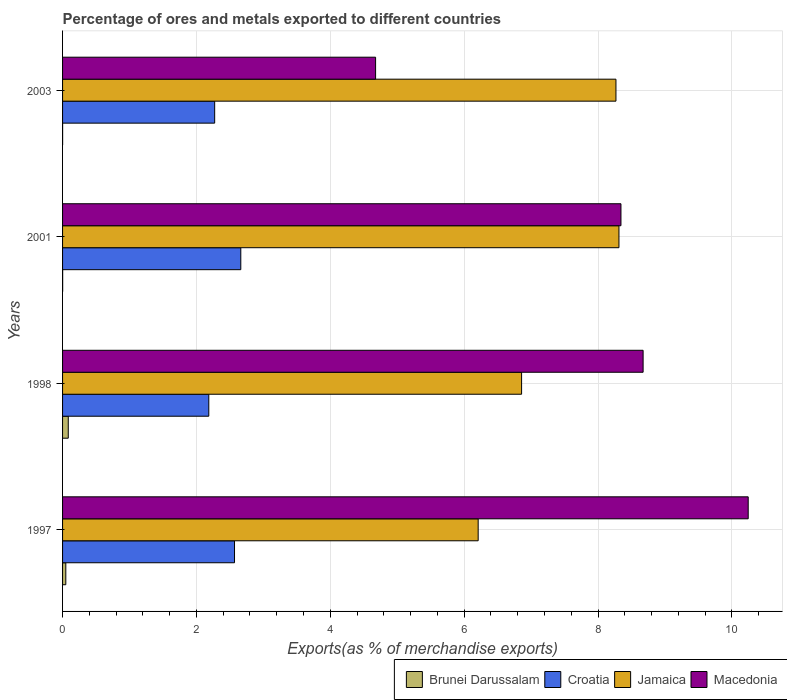Are the number of bars per tick equal to the number of legend labels?
Provide a succinct answer. Yes. What is the label of the 2nd group of bars from the top?
Offer a terse response. 2001. In how many cases, is the number of bars for a given year not equal to the number of legend labels?
Offer a very short reply. 0. What is the percentage of exports to different countries in Croatia in 1998?
Ensure brevity in your answer.  2.18. Across all years, what is the maximum percentage of exports to different countries in Brunei Darussalam?
Your response must be concise. 0.09. Across all years, what is the minimum percentage of exports to different countries in Jamaica?
Provide a succinct answer. 6.21. In which year was the percentage of exports to different countries in Croatia minimum?
Your response must be concise. 1998. What is the total percentage of exports to different countries in Jamaica in the graph?
Keep it short and to the point. 29.65. What is the difference between the percentage of exports to different countries in Macedonia in 1998 and that in 2003?
Offer a terse response. 4. What is the difference between the percentage of exports to different countries in Jamaica in 1998 and the percentage of exports to different countries in Macedonia in 2003?
Provide a short and direct response. 2.18. What is the average percentage of exports to different countries in Jamaica per year?
Ensure brevity in your answer.  7.41. In the year 1997, what is the difference between the percentage of exports to different countries in Croatia and percentage of exports to different countries in Jamaica?
Give a very brief answer. -3.64. In how many years, is the percentage of exports to different countries in Macedonia greater than 7.2 %?
Offer a very short reply. 3. What is the ratio of the percentage of exports to different countries in Croatia in 2001 to that in 2003?
Ensure brevity in your answer.  1.17. Is the difference between the percentage of exports to different countries in Croatia in 1997 and 2001 greater than the difference between the percentage of exports to different countries in Jamaica in 1997 and 2001?
Keep it short and to the point. Yes. What is the difference between the highest and the second highest percentage of exports to different countries in Brunei Darussalam?
Provide a succinct answer. 0.04. What is the difference between the highest and the lowest percentage of exports to different countries in Macedonia?
Your answer should be compact. 5.57. Is the sum of the percentage of exports to different countries in Jamaica in 1997 and 1998 greater than the maximum percentage of exports to different countries in Croatia across all years?
Your answer should be very brief. Yes. Is it the case that in every year, the sum of the percentage of exports to different countries in Jamaica and percentage of exports to different countries in Croatia is greater than the sum of percentage of exports to different countries in Brunei Darussalam and percentage of exports to different countries in Macedonia?
Your answer should be compact. No. What does the 2nd bar from the top in 2001 represents?
Ensure brevity in your answer.  Jamaica. What does the 3rd bar from the bottom in 1997 represents?
Offer a very short reply. Jamaica. Is it the case that in every year, the sum of the percentage of exports to different countries in Croatia and percentage of exports to different countries in Macedonia is greater than the percentage of exports to different countries in Jamaica?
Offer a terse response. No. How many bars are there?
Offer a very short reply. 16. Are all the bars in the graph horizontal?
Your answer should be very brief. Yes. How many years are there in the graph?
Provide a short and direct response. 4. What is the difference between two consecutive major ticks on the X-axis?
Offer a very short reply. 2. Are the values on the major ticks of X-axis written in scientific E-notation?
Give a very brief answer. No. Does the graph contain grids?
Ensure brevity in your answer.  Yes. How are the legend labels stacked?
Make the answer very short. Horizontal. What is the title of the graph?
Make the answer very short. Percentage of ores and metals exported to different countries. Does "Cambodia" appear as one of the legend labels in the graph?
Keep it short and to the point. No. What is the label or title of the X-axis?
Offer a very short reply. Exports(as % of merchandise exports). What is the label or title of the Y-axis?
Your answer should be very brief. Years. What is the Exports(as % of merchandise exports) of Brunei Darussalam in 1997?
Offer a very short reply. 0.05. What is the Exports(as % of merchandise exports) in Croatia in 1997?
Provide a succinct answer. 2.57. What is the Exports(as % of merchandise exports) in Jamaica in 1997?
Offer a very short reply. 6.21. What is the Exports(as % of merchandise exports) of Macedonia in 1997?
Make the answer very short. 10.24. What is the Exports(as % of merchandise exports) in Brunei Darussalam in 1998?
Offer a very short reply. 0.09. What is the Exports(as % of merchandise exports) in Croatia in 1998?
Your answer should be compact. 2.18. What is the Exports(as % of merchandise exports) in Jamaica in 1998?
Your answer should be very brief. 6.86. What is the Exports(as % of merchandise exports) in Macedonia in 1998?
Make the answer very short. 8.67. What is the Exports(as % of merchandise exports) of Brunei Darussalam in 2001?
Give a very brief answer. 0. What is the Exports(as % of merchandise exports) in Croatia in 2001?
Ensure brevity in your answer.  2.66. What is the Exports(as % of merchandise exports) of Jamaica in 2001?
Give a very brief answer. 8.31. What is the Exports(as % of merchandise exports) of Macedonia in 2001?
Ensure brevity in your answer.  8.34. What is the Exports(as % of merchandise exports) of Brunei Darussalam in 2003?
Offer a terse response. 0. What is the Exports(as % of merchandise exports) in Croatia in 2003?
Keep it short and to the point. 2.27. What is the Exports(as % of merchandise exports) of Jamaica in 2003?
Give a very brief answer. 8.27. What is the Exports(as % of merchandise exports) in Macedonia in 2003?
Offer a terse response. 4.68. Across all years, what is the maximum Exports(as % of merchandise exports) of Brunei Darussalam?
Give a very brief answer. 0.09. Across all years, what is the maximum Exports(as % of merchandise exports) of Croatia?
Your response must be concise. 2.66. Across all years, what is the maximum Exports(as % of merchandise exports) in Jamaica?
Your answer should be compact. 8.31. Across all years, what is the maximum Exports(as % of merchandise exports) of Macedonia?
Offer a very short reply. 10.24. Across all years, what is the minimum Exports(as % of merchandise exports) in Brunei Darussalam?
Make the answer very short. 0. Across all years, what is the minimum Exports(as % of merchandise exports) in Croatia?
Offer a terse response. 2.18. Across all years, what is the minimum Exports(as % of merchandise exports) in Jamaica?
Give a very brief answer. 6.21. Across all years, what is the minimum Exports(as % of merchandise exports) of Macedonia?
Make the answer very short. 4.68. What is the total Exports(as % of merchandise exports) of Brunei Darussalam in the graph?
Keep it short and to the point. 0.14. What is the total Exports(as % of merchandise exports) of Croatia in the graph?
Offer a terse response. 9.69. What is the total Exports(as % of merchandise exports) in Jamaica in the graph?
Keep it short and to the point. 29.65. What is the total Exports(as % of merchandise exports) in Macedonia in the graph?
Your answer should be compact. 31.94. What is the difference between the Exports(as % of merchandise exports) in Brunei Darussalam in 1997 and that in 1998?
Offer a very short reply. -0.04. What is the difference between the Exports(as % of merchandise exports) of Croatia in 1997 and that in 1998?
Ensure brevity in your answer.  0.38. What is the difference between the Exports(as % of merchandise exports) of Jamaica in 1997 and that in 1998?
Your answer should be very brief. -0.65. What is the difference between the Exports(as % of merchandise exports) in Macedonia in 1997 and that in 1998?
Offer a very short reply. 1.57. What is the difference between the Exports(as % of merchandise exports) of Brunei Darussalam in 1997 and that in 2001?
Offer a terse response. 0.05. What is the difference between the Exports(as % of merchandise exports) in Croatia in 1997 and that in 2001?
Ensure brevity in your answer.  -0.09. What is the difference between the Exports(as % of merchandise exports) in Jamaica in 1997 and that in 2001?
Keep it short and to the point. -2.1. What is the difference between the Exports(as % of merchandise exports) in Macedonia in 1997 and that in 2001?
Provide a succinct answer. 1.9. What is the difference between the Exports(as % of merchandise exports) in Brunei Darussalam in 1997 and that in 2003?
Your response must be concise. 0.05. What is the difference between the Exports(as % of merchandise exports) of Croatia in 1997 and that in 2003?
Keep it short and to the point. 0.3. What is the difference between the Exports(as % of merchandise exports) of Jamaica in 1997 and that in 2003?
Provide a short and direct response. -2.06. What is the difference between the Exports(as % of merchandise exports) in Macedonia in 1997 and that in 2003?
Provide a short and direct response. 5.57. What is the difference between the Exports(as % of merchandise exports) of Brunei Darussalam in 1998 and that in 2001?
Provide a short and direct response. 0.08. What is the difference between the Exports(as % of merchandise exports) of Croatia in 1998 and that in 2001?
Provide a short and direct response. -0.48. What is the difference between the Exports(as % of merchandise exports) of Jamaica in 1998 and that in 2001?
Provide a succinct answer. -1.45. What is the difference between the Exports(as % of merchandise exports) in Macedonia in 1998 and that in 2001?
Your answer should be very brief. 0.33. What is the difference between the Exports(as % of merchandise exports) of Brunei Darussalam in 1998 and that in 2003?
Keep it short and to the point. 0.08. What is the difference between the Exports(as % of merchandise exports) of Croatia in 1998 and that in 2003?
Keep it short and to the point. -0.09. What is the difference between the Exports(as % of merchandise exports) of Jamaica in 1998 and that in 2003?
Offer a very short reply. -1.41. What is the difference between the Exports(as % of merchandise exports) in Macedonia in 1998 and that in 2003?
Provide a short and direct response. 4. What is the difference between the Exports(as % of merchandise exports) of Croatia in 2001 and that in 2003?
Give a very brief answer. 0.39. What is the difference between the Exports(as % of merchandise exports) in Jamaica in 2001 and that in 2003?
Provide a succinct answer. 0.04. What is the difference between the Exports(as % of merchandise exports) in Macedonia in 2001 and that in 2003?
Provide a short and direct response. 3.67. What is the difference between the Exports(as % of merchandise exports) in Brunei Darussalam in 1997 and the Exports(as % of merchandise exports) in Croatia in 1998?
Make the answer very short. -2.14. What is the difference between the Exports(as % of merchandise exports) of Brunei Darussalam in 1997 and the Exports(as % of merchandise exports) of Jamaica in 1998?
Make the answer very short. -6.81. What is the difference between the Exports(as % of merchandise exports) in Brunei Darussalam in 1997 and the Exports(as % of merchandise exports) in Macedonia in 1998?
Your answer should be compact. -8.62. What is the difference between the Exports(as % of merchandise exports) of Croatia in 1997 and the Exports(as % of merchandise exports) of Jamaica in 1998?
Your answer should be very brief. -4.29. What is the difference between the Exports(as % of merchandise exports) of Croatia in 1997 and the Exports(as % of merchandise exports) of Macedonia in 1998?
Offer a terse response. -6.1. What is the difference between the Exports(as % of merchandise exports) in Jamaica in 1997 and the Exports(as % of merchandise exports) in Macedonia in 1998?
Make the answer very short. -2.46. What is the difference between the Exports(as % of merchandise exports) in Brunei Darussalam in 1997 and the Exports(as % of merchandise exports) in Croatia in 2001?
Make the answer very short. -2.61. What is the difference between the Exports(as % of merchandise exports) in Brunei Darussalam in 1997 and the Exports(as % of merchandise exports) in Jamaica in 2001?
Offer a very short reply. -8.26. What is the difference between the Exports(as % of merchandise exports) in Brunei Darussalam in 1997 and the Exports(as % of merchandise exports) in Macedonia in 2001?
Your answer should be compact. -8.29. What is the difference between the Exports(as % of merchandise exports) in Croatia in 1997 and the Exports(as % of merchandise exports) in Jamaica in 2001?
Offer a terse response. -5.74. What is the difference between the Exports(as % of merchandise exports) of Croatia in 1997 and the Exports(as % of merchandise exports) of Macedonia in 2001?
Give a very brief answer. -5.77. What is the difference between the Exports(as % of merchandise exports) of Jamaica in 1997 and the Exports(as % of merchandise exports) of Macedonia in 2001?
Offer a terse response. -2.13. What is the difference between the Exports(as % of merchandise exports) in Brunei Darussalam in 1997 and the Exports(as % of merchandise exports) in Croatia in 2003?
Provide a succinct answer. -2.22. What is the difference between the Exports(as % of merchandise exports) in Brunei Darussalam in 1997 and the Exports(as % of merchandise exports) in Jamaica in 2003?
Provide a short and direct response. -8.22. What is the difference between the Exports(as % of merchandise exports) in Brunei Darussalam in 1997 and the Exports(as % of merchandise exports) in Macedonia in 2003?
Your answer should be compact. -4.63. What is the difference between the Exports(as % of merchandise exports) in Croatia in 1997 and the Exports(as % of merchandise exports) in Jamaica in 2003?
Offer a very short reply. -5.7. What is the difference between the Exports(as % of merchandise exports) in Croatia in 1997 and the Exports(as % of merchandise exports) in Macedonia in 2003?
Your answer should be compact. -2.11. What is the difference between the Exports(as % of merchandise exports) of Jamaica in 1997 and the Exports(as % of merchandise exports) of Macedonia in 2003?
Offer a terse response. 1.53. What is the difference between the Exports(as % of merchandise exports) in Brunei Darussalam in 1998 and the Exports(as % of merchandise exports) in Croatia in 2001?
Provide a succinct answer. -2.58. What is the difference between the Exports(as % of merchandise exports) of Brunei Darussalam in 1998 and the Exports(as % of merchandise exports) of Jamaica in 2001?
Give a very brief answer. -8.23. What is the difference between the Exports(as % of merchandise exports) in Brunei Darussalam in 1998 and the Exports(as % of merchandise exports) in Macedonia in 2001?
Offer a very short reply. -8.26. What is the difference between the Exports(as % of merchandise exports) in Croatia in 1998 and the Exports(as % of merchandise exports) in Jamaica in 2001?
Keep it short and to the point. -6.13. What is the difference between the Exports(as % of merchandise exports) of Croatia in 1998 and the Exports(as % of merchandise exports) of Macedonia in 2001?
Provide a succinct answer. -6.16. What is the difference between the Exports(as % of merchandise exports) of Jamaica in 1998 and the Exports(as % of merchandise exports) of Macedonia in 2001?
Provide a succinct answer. -1.48. What is the difference between the Exports(as % of merchandise exports) in Brunei Darussalam in 1998 and the Exports(as % of merchandise exports) in Croatia in 2003?
Provide a succinct answer. -2.19. What is the difference between the Exports(as % of merchandise exports) in Brunei Darussalam in 1998 and the Exports(as % of merchandise exports) in Jamaica in 2003?
Your answer should be very brief. -8.18. What is the difference between the Exports(as % of merchandise exports) in Brunei Darussalam in 1998 and the Exports(as % of merchandise exports) in Macedonia in 2003?
Your answer should be very brief. -4.59. What is the difference between the Exports(as % of merchandise exports) of Croatia in 1998 and the Exports(as % of merchandise exports) of Jamaica in 2003?
Offer a very short reply. -6.08. What is the difference between the Exports(as % of merchandise exports) in Croatia in 1998 and the Exports(as % of merchandise exports) in Macedonia in 2003?
Offer a terse response. -2.49. What is the difference between the Exports(as % of merchandise exports) in Jamaica in 1998 and the Exports(as % of merchandise exports) in Macedonia in 2003?
Make the answer very short. 2.18. What is the difference between the Exports(as % of merchandise exports) in Brunei Darussalam in 2001 and the Exports(as % of merchandise exports) in Croatia in 2003?
Ensure brevity in your answer.  -2.27. What is the difference between the Exports(as % of merchandise exports) in Brunei Darussalam in 2001 and the Exports(as % of merchandise exports) in Jamaica in 2003?
Your response must be concise. -8.27. What is the difference between the Exports(as % of merchandise exports) in Brunei Darussalam in 2001 and the Exports(as % of merchandise exports) in Macedonia in 2003?
Give a very brief answer. -4.68. What is the difference between the Exports(as % of merchandise exports) of Croatia in 2001 and the Exports(as % of merchandise exports) of Jamaica in 2003?
Your response must be concise. -5.6. What is the difference between the Exports(as % of merchandise exports) of Croatia in 2001 and the Exports(as % of merchandise exports) of Macedonia in 2003?
Give a very brief answer. -2.01. What is the difference between the Exports(as % of merchandise exports) of Jamaica in 2001 and the Exports(as % of merchandise exports) of Macedonia in 2003?
Give a very brief answer. 3.64. What is the average Exports(as % of merchandise exports) of Brunei Darussalam per year?
Give a very brief answer. 0.03. What is the average Exports(as % of merchandise exports) of Croatia per year?
Ensure brevity in your answer.  2.42. What is the average Exports(as % of merchandise exports) in Jamaica per year?
Keep it short and to the point. 7.41. What is the average Exports(as % of merchandise exports) in Macedonia per year?
Keep it short and to the point. 7.98. In the year 1997, what is the difference between the Exports(as % of merchandise exports) in Brunei Darussalam and Exports(as % of merchandise exports) in Croatia?
Make the answer very short. -2.52. In the year 1997, what is the difference between the Exports(as % of merchandise exports) of Brunei Darussalam and Exports(as % of merchandise exports) of Jamaica?
Your answer should be compact. -6.16. In the year 1997, what is the difference between the Exports(as % of merchandise exports) of Brunei Darussalam and Exports(as % of merchandise exports) of Macedonia?
Your answer should be very brief. -10.19. In the year 1997, what is the difference between the Exports(as % of merchandise exports) in Croatia and Exports(as % of merchandise exports) in Jamaica?
Your answer should be very brief. -3.64. In the year 1997, what is the difference between the Exports(as % of merchandise exports) in Croatia and Exports(as % of merchandise exports) in Macedonia?
Your response must be concise. -7.67. In the year 1997, what is the difference between the Exports(as % of merchandise exports) in Jamaica and Exports(as % of merchandise exports) in Macedonia?
Your answer should be very brief. -4.03. In the year 1998, what is the difference between the Exports(as % of merchandise exports) of Brunei Darussalam and Exports(as % of merchandise exports) of Croatia?
Keep it short and to the point. -2.1. In the year 1998, what is the difference between the Exports(as % of merchandise exports) of Brunei Darussalam and Exports(as % of merchandise exports) of Jamaica?
Provide a short and direct response. -6.77. In the year 1998, what is the difference between the Exports(as % of merchandise exports) in Brunei Darussalam and Exports(as % of merchandise exports) in Macedonia?
Your answer should be compact. -8.59. In the year 1998, what is the difference between the Exports(as % of merchandise exports) of Croatia and Exports(as % of merchandise exports) of Jamaica?
Ensure brevity in your answer.  -4.67. In the year 1998, what is the difference between the Exports(as % of merchandise exports) in Croatia and Exports(as % of merchandise exports) in Macedonia?
Make the answer very short. -6.49. In the year 1998, what is the difference between the Exports(as % of merchandise exports) of Jamaica and Exports(as % of merchandise exports) of Macedonia?
Make the answer very short. -1.82. In the year 2001, what is the difference between the Exports(as % of merchandise exports) in Brunei Darussalam and Exports(as % of merchandise exports) in Croatia?
Your answer should be very brief. -2.66. In the year 2001, what is the difference between the Exports(as % of merchandise exports) of Brunei Darussalam and Exports(as % of merchandise exports) of Jamaica?
Make the answer very short. -8.31. In the year 2001, what is the difference between the Exports(as % of merchandise exports) in Brunei Darussalam and Exports(as % of merchandise exports) in Macedonia?
Make the answer very short. -8.34. In the year 2001, what is the difference between the Exports(as % of merchandise exports) in Croatia and Exports(as % of merchandise exports) in Jamaica?
Offer a very short reply. -5.65. In the year 2001, what is the difference between the Exports(as % of merchandise exports) of Croatia and Exports(as % of merchandise exports) of Macedonia?
Provide a short and direct response. -5.68. In the year 2001, what is the difference between the Exports(as % of merchandise exports) of Jamaica and Exports(as % of merchandise exports) of Macedonia?
Provide a succinct answer. -0.03. In the year 2003, what is the difference between the Exports(as % of merchandise exports) in Brunei Darussalam and Exports(as % of merchandise exports) in Croatia?
Offer a terse response. -2.27. In the year 2003, what is the difference between the Exports(as % of merchandise exports) of Brunei Darussalam and Exports(as % of merchandise exports) of Jamaica?
Offer a terse response. -8.27. In the year 2003, what is the difference between the Exports(as % of merchandise exports) in Brunei Darussalam and Exports(as % of merchandise exports) in Macedonia?
Provide a short and direct response. -4.68. In the year 2003, what is the difference between the Exports(as % of merchandise exports) in Croatia and Exports(as % of merchandise exports) in Jamaica?
Your response must be concise. -6. In the year 2003, what is the difference between the Exports(as % of merchandise exports) of Croatia and Exports(as % of merchandise exports) of Macedonia?
Offer a very short reply. -2.4. In the year 2003, what is the difference between the Exports(as % of merchandise exports) of Jamaica and Exports(as % of merchandise exports) of Macedonia?
Offer a terse response. 3.59. What is the ratio of the Exports(as % of merchandise exports) of Brunei Darussalam in 1997 to that in 1998?
Your response must be concise. 0.57. What is the ratio of the Exports(as % of merchandise exports) in Croatia in 1997 to that in 1998?
Make the answer very short. 1.18. What is the ratio of the Exports(as % of merchandise exports) of Jamaica in 1997 to that in 1998?
Your response must be concise. 0.91. What is the ratio of the Exports(as % of merchandise exports) in Macedonia in 1997 to that in 1998?
Give a very brief answer. 1.18. What is the ratio of the Exports(as % of merchandise exports) in Brunei Darussalam in 1997 to that in 2001?
Your answer should be compact. 39.21. What is the ratio of the Exports(as % of merchandise exports) in Croatia in 1997 to that in 2001?
Offer a terse response. 0.96. What is the ratio of the Exports(as % of merchandise exports) of Jamaica in 1997 to that in 2001?
Offer a very short reply. 0.75. What is the ratio of the Exports(as % of merchandise exports) in Macedonia in 1997 to that in 2001?
Make the answer very short. 1.23. What is the ratio of the Exports(as % of merchandise exports) in Brunei Darussalam in 1997 to that in 2003?
Provide a succinct answer. 64.77. What is the ratio of the Exports(as % of merchandise exports) of Croatia in 1997 to that in 2003?
Keep it short and to the point. 1.13. What is the ratio of the Exports(as % of merchandise exports) in Jamaica in 1997 to that in 2003?
Provide a short and direct response. 0.75. What is the ratio of the Exports(as % of merchandise exports) in Macedonia in 1997 to that in 2003?
Offer a very short reply. 2.19. What is the ratio of the Exports(as % of merchandise exports) in Brunei Darussalam in 1998 to that in 2001?
Provide a succinct answer. 68.75. What is the ratio of the Exports(as % of merchandise exports) of Croatia in 1998 to that in 2001?
Offer a very short reply. 0.82. What is the ratio of the Exports(as % of merchandise exports) of Jamaica in 1998 to that in 2001?
Offer a terse response. 0.82. What is the ratio of the Exports(as % of merchandise exports) in Macedonia in 1998 to that in 2001?
Offer a very short reply. 1.04. What is the ratio of the Exports(as % of merchandise exports) in Brunei Darussalam in 1998 to that in 2003?
Your answer should be compact. 113.56. What is the ratio of the Exports(as % of merchandise exports) of Croatia in 1998 to that in 2003?
Ensure brevity in your answer.  0.96. What is the ratio of the Exports(as % of merchandise exports) in Jamaica in 1998 to that in 2003?
Offer a very short reply. 0.83. What is the ratio of the Exports(as % of merchandise exports) of Macedonia in 1998 to that in 2003?
Your response must be concise. 1.85. What is the ratio of the Exports(as % of merchandise exports) in Brunei Darussalam in 2001 to that in 2003?
Provide a succinct answer. 1.65. What is the ratio of the Exports(as % of merchandise exports) of Croatia in 2001 to that in 2003?
Ensure brevity in your answer.  1.17. What is the ratio of the Exports(as % of merchandise exports) of Jamaica in 2001 to that in 2003?
Offer a very short reply. 1.01. What is the ratio of the Exports(as % of merchandise exports) of Macedonia in 2001 to that in 2003?
Your answer should be compact. 1.78. What is the difference between the highest and the second highest Exports(as % of merchandise exports) in Brunei Darussalam?
Make the answer very short. 0.04. What is the difference between the highest and the second highest Exports(as % of merchandise exports) of Croatia?
Provide a succinct answer. 0.09. What is the difference between the highest and the second highest Exports(as % of merchandise exports) of Jamaica?
Provide a succinct answer. 0.04. What is the difference between the highest and the second highest Exports(as % of merchandise exports) in Macedonia?
Give a very brief answer. 1.57. What is the difference between the highest and the lowest Exports(as % of merchandise exports) of Brunei Darussalam?
Make the answer very short. 0.08. What is the difference between the highest and the lowest Exports(as % of merchandise exports) of Croatia?
Offer a very short reply. 0.48. What is the difference between the highest and the lowest Exports(as % of merchandise exports) of Jamaica?
Make the answer very short. 2.1. What is the difference between the highest and the lowest Exports(as % of merchandise exports) of Macedonia?
Keep it short and to the point. 5.57. 